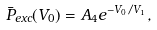<formula> <loc_0><loc_0><loc_500><loc_500>\bar { P } _ { e x c } ( V _ { 0 } ) = A _ { 4 } e ^ { - V _ { 0 } / V _ { 1 } } ,</formula> 